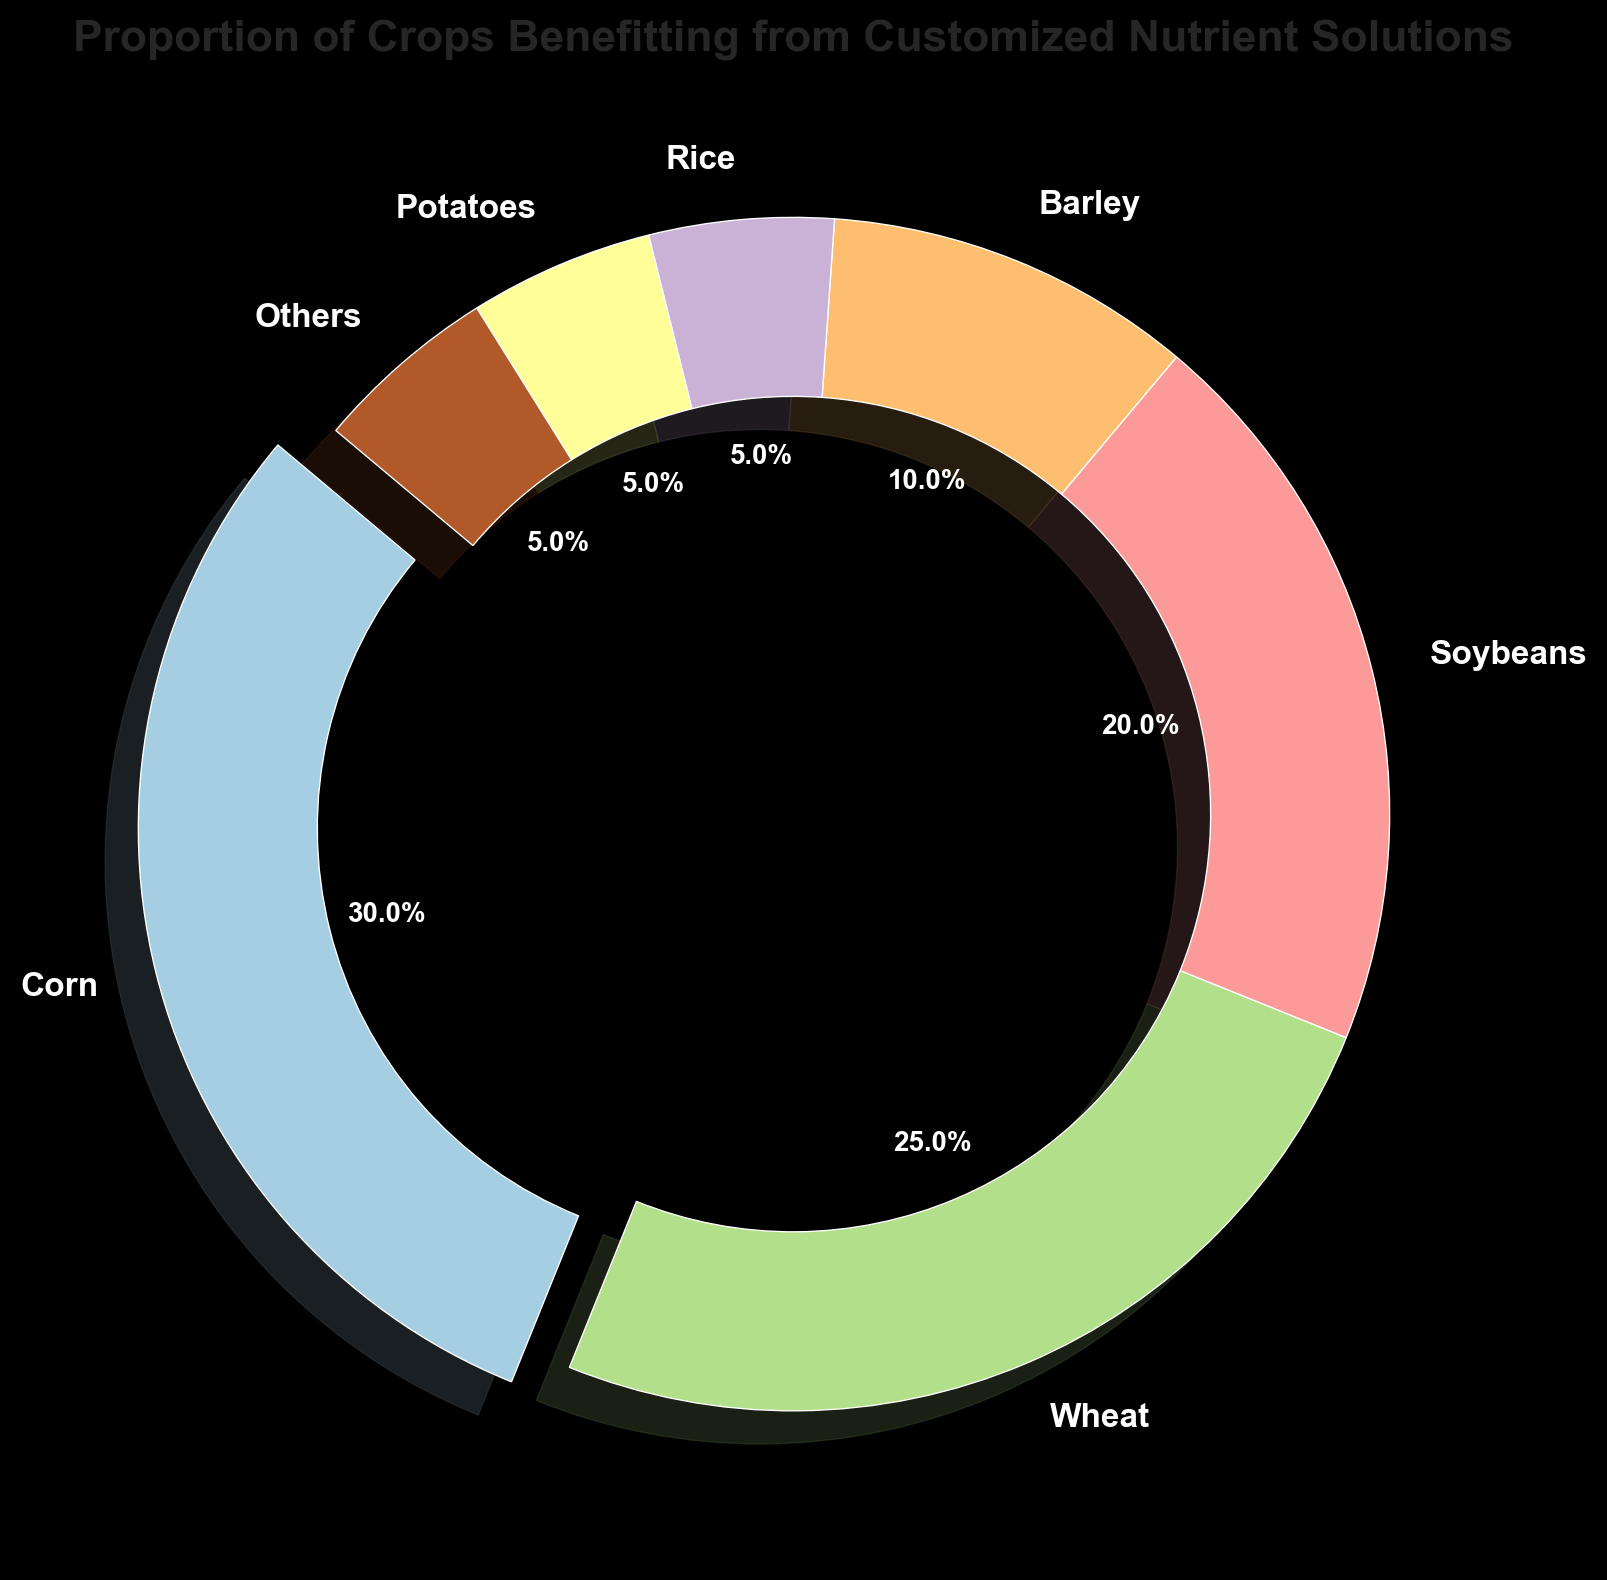What is the crop with the highest proportion benefitting from customized nutrient solutions? By looking at the pie chart, we can see that Corn has the largest slice, indicating it has the highest proportion.
Answer: Corn What is the total proportion of crops that benefit equally (5%) from customized nutrient solutions? By examining the pie chart, we see that Rice, Potatoes, and Others each have a 5% proportion. Summing them up, 5% + 5% + 5% = 15%.
Answer: 15% What is the proportion difference between Corn and Wheat? The chart shows Corn has 30% and Wheat has 25%. The difference is calculated as 30% - 25% = 5%.
Answer: 5% How does the proportion of Soybeans compare to Barley? Based on the pie chart, Soybeans have a proportion of 20% and Barley has 10%. Soybeans' proportion is higher than Barley's by 20% - 10% = 10%.
Answer: Soybeans have 10% more Which color represents the crop with the lowest proportion? From the pie chart colors and crop proportions, Rice has the lowest proportion at 5%, represented with its respective color.
Answer: The color representing Rice What is the average proportion of Corn, Wheat, and Soybeans? The proportions for Corn, Wheat, and Soybeans are 30%, 25%, and 20%, respectively. To find the average: (30% + 25% + 20%) / 3 = 25%.
Answer: 25% Are any two crops proportiona equally in benefitting from customized nutrient solutions? By observing the pie chart, we notice that Rice, Potatoes, and Others each have a 5% proportion.
Answer: Rice, Potatoes, and Others (each 5%) Calculate the total percentage of crops that benefit from customized nutrient solutions which is less than 20%. From the chart, Barley, Rice, Potatoes, and Others each have proportions of 10%, 5%, 5%, and 5%, respectively. Summing them up: 10% + 5% + 5% + 5% = 25%.
Answer: 25% What is the angular size of the Corn segment in the pie chart if the circle is divided proportionally? Corn represents 30% of the pie chart. Since a full circle is 360 degrees, the angle for Corn is 0.30 * 360 = 108 degrees.
Answer: 108 degrees 